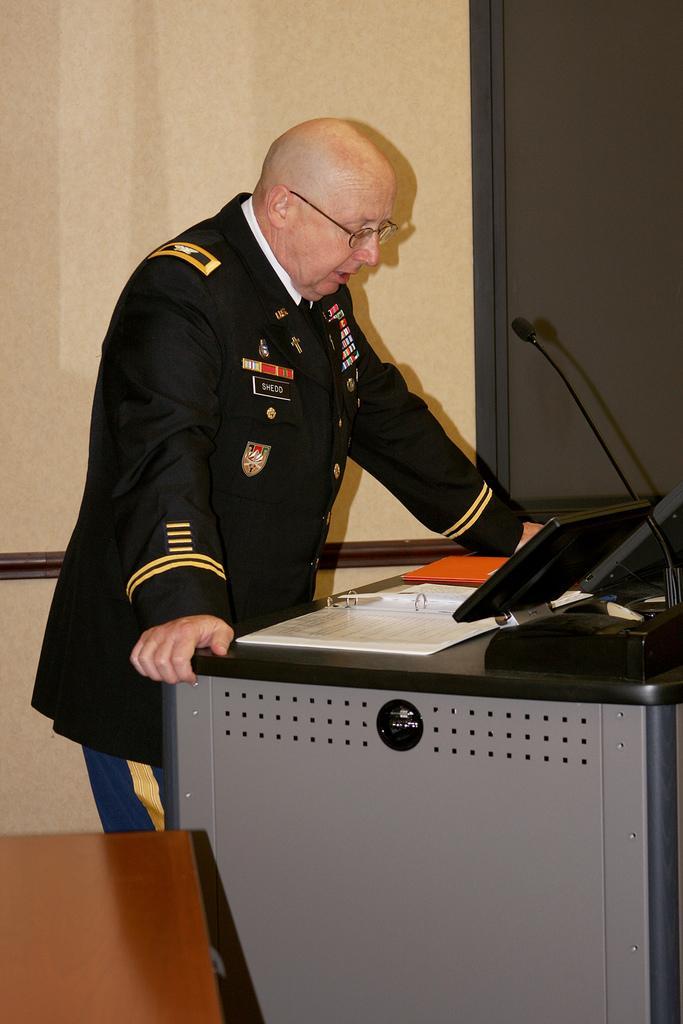Please provide a concise description of this image. This is the man standing. I think this is the table with a monitor, mike and papers. This looks like a chair. Here is the wall. This man wore a uniform. 